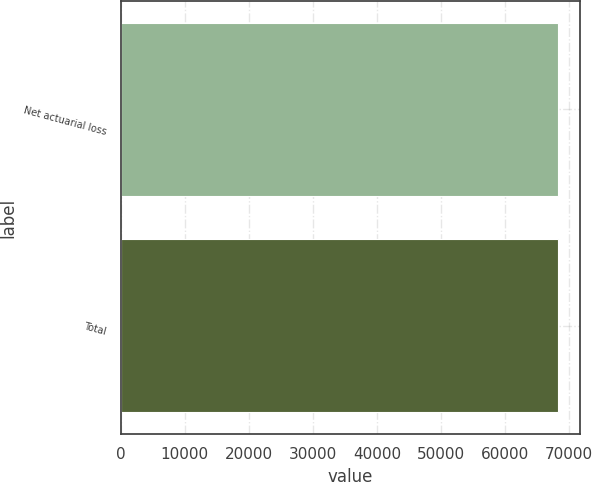Convert chart. <chart><loc_0><loc_0><loc_500><loc_500><bar_chart><fcel>Net actuarial loss<fcel>Total<nl><fcel>68224<fcel>68224.1<nl></chart> 